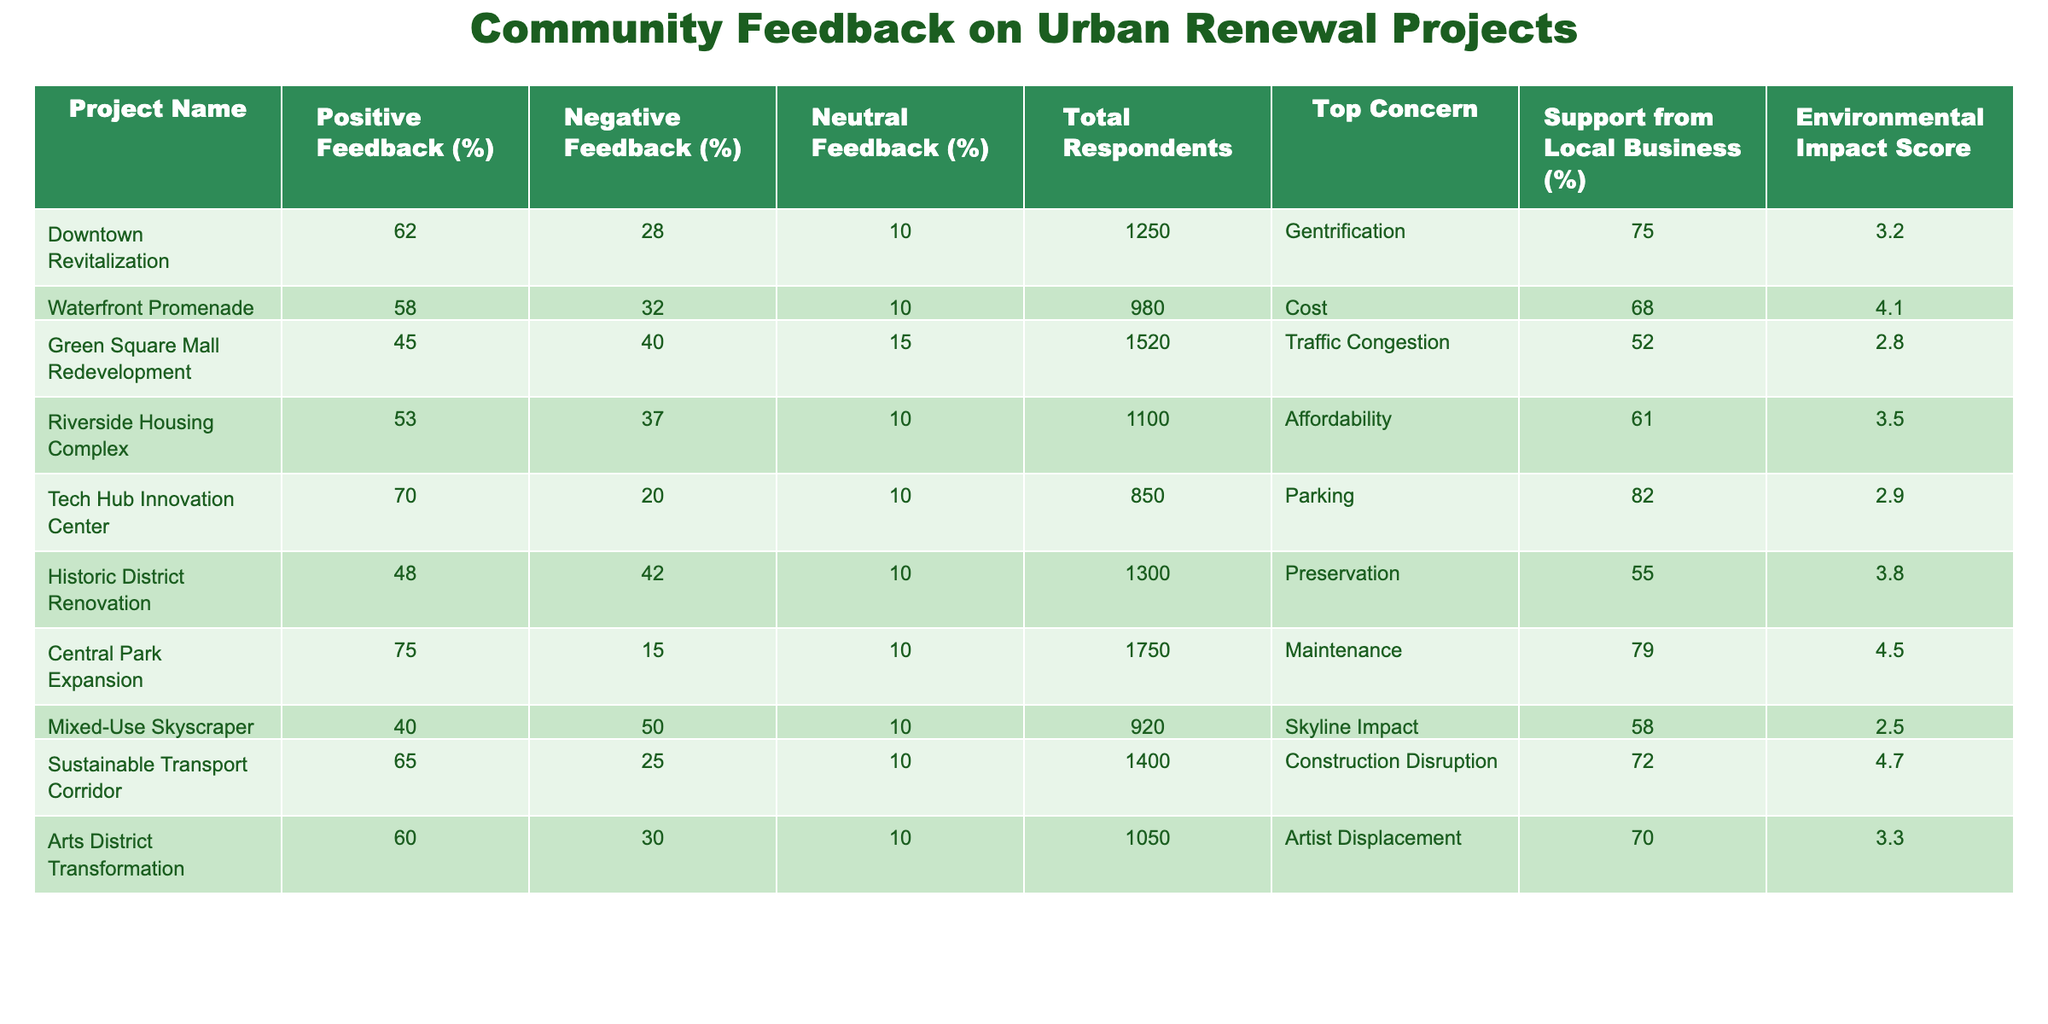What is the project with the highest positive feedback percentage? By looking at the "Positive Feedback (%)" column, the "Central Park Expansion" has the highest value at 75%.
Answer: Central Park Expansion What is the total number of respondents for the "Green Square Mall Redevelopment"? In the "Total Respondents" column, the value for "Green Square Mall Redevelopment" is 1520.
Answer: 1520 Which project has the lowest environmental impact score? The lowest value in the "Environmental Impact Score" column is for the "Mixed-Use Skyscraper," which has a score of 2.5.
Answer: Mixed-Use Skyscraper How many projects received more than 60% positive feedback? By checking the "Positive Feedback (%)" column, the projects that received more than 60% positive feedback are "Downtown Revitalization," "Tech Hub Innovation Center," "Central Park Expansion," and "Sustainable Transport Corridor," totaling four projects.
Answer: 4 Is the negative feedback for the "Historic District Renovation" greater than 40%? In the "Negative Feedback (%)" column, the value for "Historic District Renovation" is 42%, which is greater than 40%.
Answer: Yes What percentage of respondents gave neutral feedback for the "Riverside Housing Complex"? The "Neutral Feedback (%)" column shows the value for "Riverside Housing Complex" is 10%.
Answer: 10% What is the average support from local businesses for projects with more than 50% positive feedback? The projects with more than 50% positive feedback are "Downtown Revitalization," "Tech Hub Innovation Center," "Central Park Expansion," and "Sustainable Transport Corridor." Calculating their support results: (75 + 82 + 79 + 72) / 4 = 76.
Answer: 76% Which project has the biggest total number of respondents, and what is that number? The "Central Park Expansion" has the largest total respondents figure, which is 1750.
Answer: 1750 What is the top concern for the "Tech Hub Innovation Center"? The "Top Concern" for the "Tech Hub Innovation Center" is "Parking."
Answer: Parking For which project is "Gentrification" identified as the top concern? The "Top Concern" for the "Downtown Revitalization" is "Gentrification."
Answer: Downtown Revitalization 